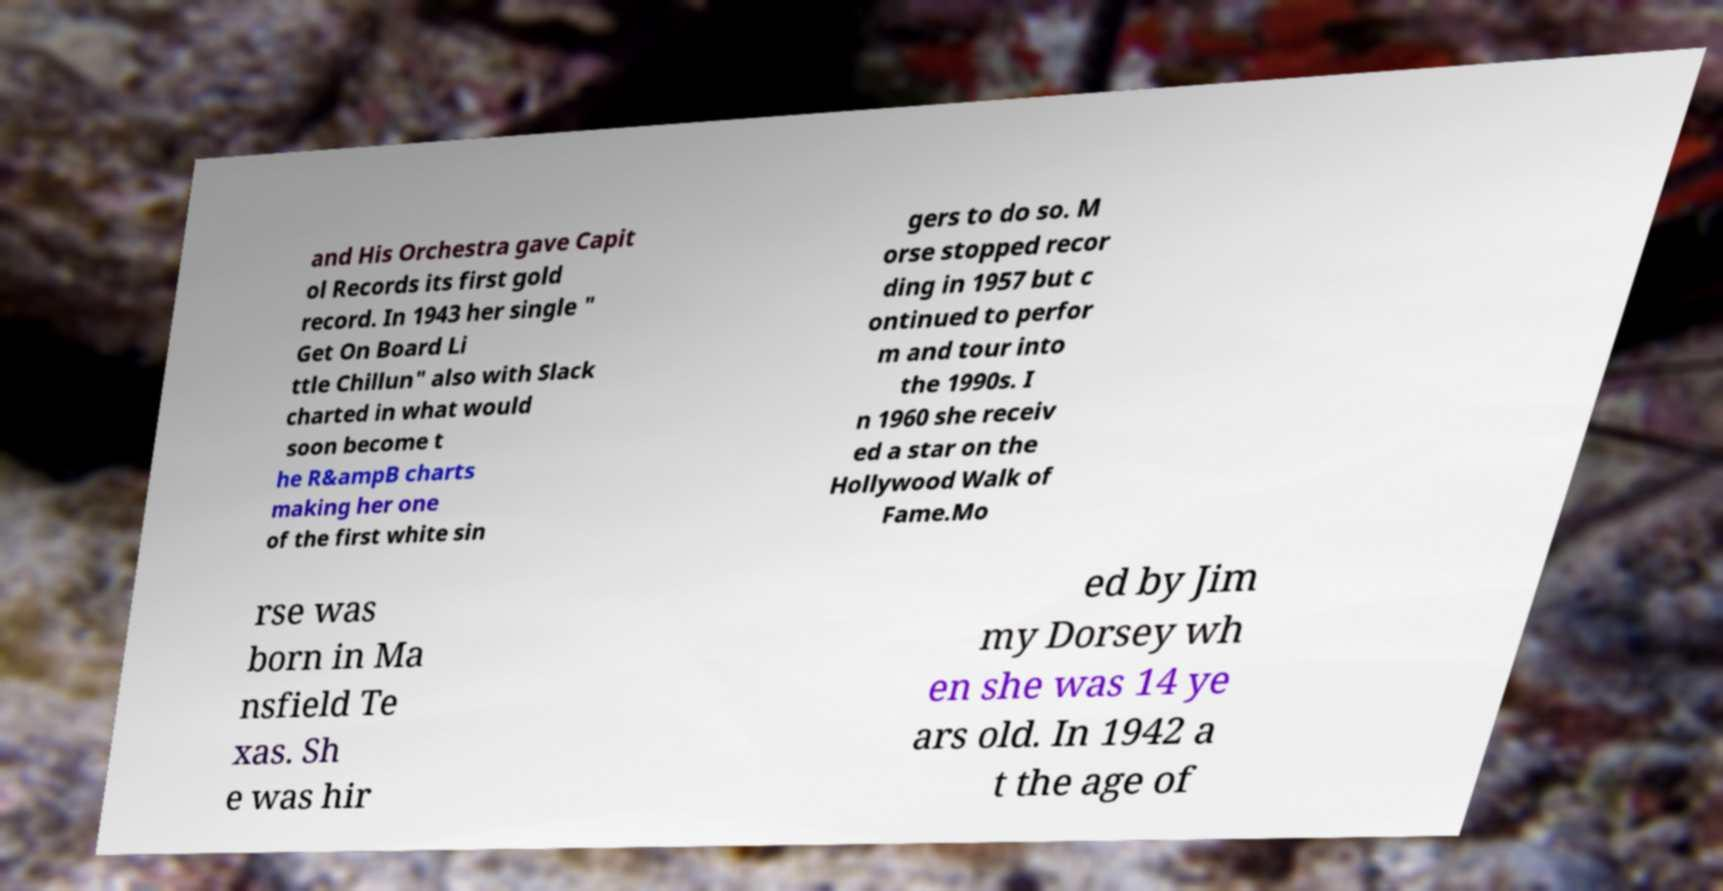Please read and relay the text visible in this image. What does it say? and His Orchestra gave Capit ol Records its first gold record. In 1943 her single " Get On Board Li ttle Chillun" also with Slack charted in what would soon become t he R&ampB charts making her one of the first white sin gers to do so. M orse stopped recor ding in 1957 but c ontinued to perfor m and tour into the 1990s. I n 1960 she receiv ed a star on the Hollywood Walk of Fame.Mo rse was born in Ma nsfield Te xas. Sh e was hir ed by Jim my Dorsey wh en she was 14 ye ars old. In 1942 a t the age of 